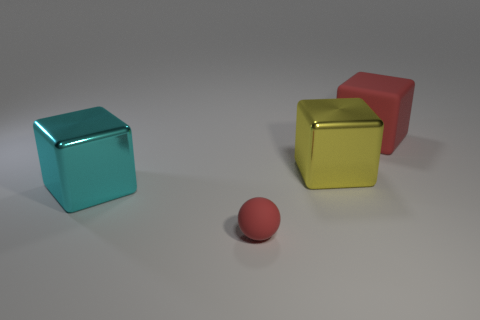Subtract all cyan cubes. How many cubes are left? 2 Add 2 big blue shiny spheres. How many objects exist? 6 Subtract all red cubes. How many cubes are left? 2 Subtract 1 spheres. How many spheres are left? 0 Subtract all cubes. How many objects are left? 1 Subtract all blue spheres. Subtract all purple blocks. How many spheres are left? 1 Subtract all gray cylinders. How many red blocks are left? 1 Subtract all matte things. Subtract all large yellow balls. How many objects are left? 2 Add 3 red matte objects. How many red matte objects are left? 5 Add 4 small balls. How many small balls exist? 5 